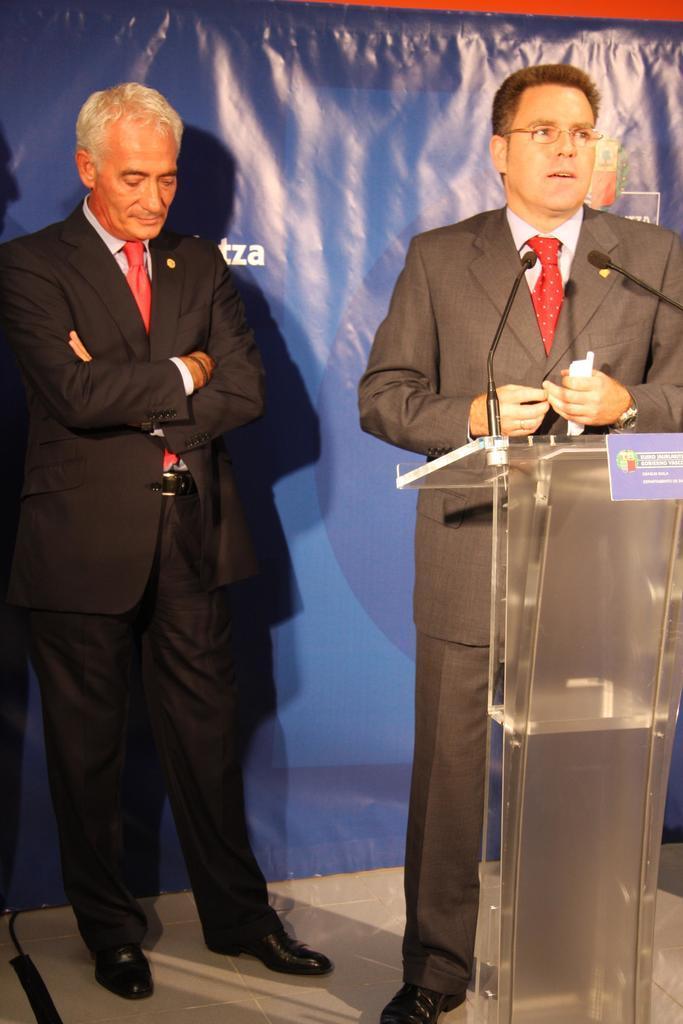Describe this image in one or two sentences. In this image there are two persons standing, a person is talking, a person is holding a paper, there is a podium, there is a microphone, at the background of the image there is a banner truncated, there is text on the banner, there is a wire truncated towards the bottom of the image. 